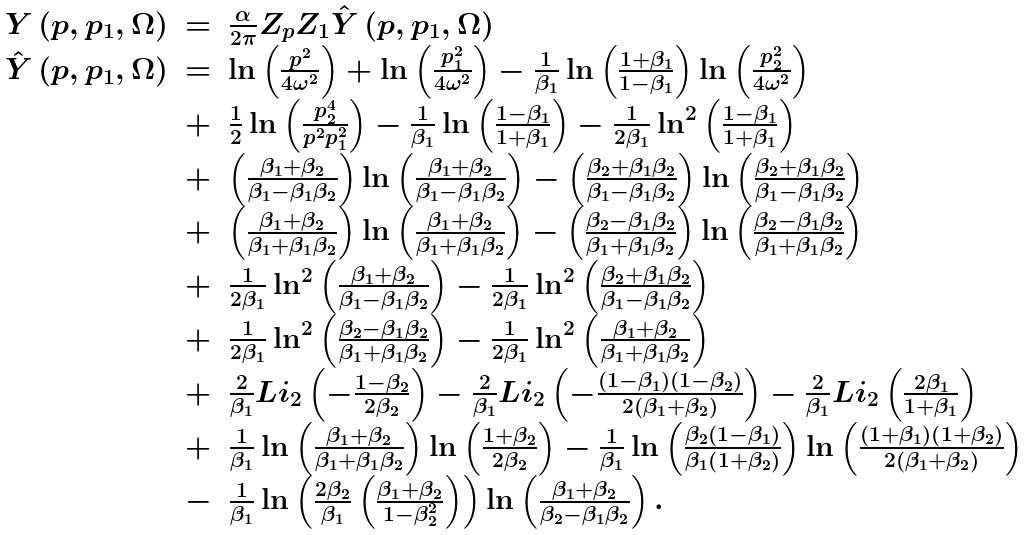<formula> <loc_0><loc_0><loc_500><loc_500>\begin{array} { l c l } Y \left ( p , p _ { 1 } , \Omega \right ) & = & \frac { \alpha } { 2 \pi } Z _ { p } Z _ { 1 } \hat { Y } \left ( p , p _ { 1 } , \Omega \right ) \\ \hat { Y } \left ( p , p _ { 1 } , \Omega \right ) & = & \ln \left ( \frac { p ^ { 2 } } { 4 \omega ^ { 2 } } \right ) + \ln \left ( \frac { p _ { 1 } ^ { 2 } } { 4 \omega ^ { 2 } } \right ) - \frac { 1 } { \beta _ { 1 } } \ln \left ( \frac { 1 + \beta _ { 1 } } { 1 - \beta _ { 1 } } \right ) \ln \left ( \frac { p _ { 2 } ^ { 2 } } { 4 \omega ^ { 2 } } \right ) \\ & + & \frac { 1 } { 2 } \ln \left ( \frac { p _ { 2 } ^ { 4 } } { p ^ { 2 } p _ { 1 } ^ { 2 } } \right ) - \frac { 1 } { \beta _ { 1 } } \ln \left ( \frac { 1 - \beta _ { 1 } } { 1 + \beta _ { 1 } } \right ) - \frac { 1 } { 2 \beta _ { 1 } } \ln ^ { 2 } \left ( \frac { 1 - \beta _ { 1 } } { 1 + \beta _ { 1 } } \right ) \\ & + & \left ( \frac { \beta _ { 1 } + \beta _ { 2 } } { \beta _ { 1 } - \beta _ { 1 } \beta _ { 2 } } \right ) \ln \left ( \frac { \beta _ { 1 } + \beta _ { 2 } } { \beta _ { 1 } - \beta _ { 1 } \beta _ { 2 } } \right ) - \left ( \frac { \beta _ { 2 } + \beta _ { 1 } \beta _ { 2 } } { \beta _ { 1 } - \beta _ { 1 } \beta _ { 2 } } \right ) \ln \left ( \frac { \beta _ { 2 } + \beta _ { 1 } \beta _ { 2 } } { \beta _ { 1 } - \beta _ { 1 } \beta _ { 2 } } \right ) \\ & + & \left ( \frac { \beta _ { 1 } + \beta _ { 2 } } { \beta _ { 1 } + \beta _ { 1 } \beta _ { 2 } } \right ) \ln \left ( \frac { \beta _ { 1 } + \beta _ { 2 } } { \beta _ { 1 } + \beta _ { 1 } \beta _ { 2 } } \right ) - \left ( \frac { \beta _ { 2 } - \beta _ { 1 } \beta _ { 2 } } { \beta _ { 1 } + \beta _ { 1 } \beta _ { 2 } } \right ) \ln \left ( \frac { \beta _ { 2 } - \beta _ { 1 } \beta _ { 2 } } { \beta _ { 1 } + \beta _ { 1 } \beta _ { 2 } } \right ) \\ & + & \frac { 1 } { 2 \beta _ { 1 } } \ln ^ { 2 } \left ( \frac { \beta _ { 1 } + \beta _ { 2 } } { \beta _ { 1 } - \beta _ { 1 } \beta _ { 2 } } \right ) - \frac { 1 } { 2 \beta _ { 1 } } \ln ^ { 2 } \left ( \frac { \beta _ { 2 } + \beta _ { 1 } \beta _ { 2 } } { \beta _ { 1 } - \beta _ { 1 } \beta _ { 2 } } \right ) \\ & + & \frac { 1 } { 2 \beta _ { 1 } } \ln ^ { 2 } \left ( \frac { \beta _ { 2 } - \beta _ { 1 } \beta _ { 2 } } { \beta _ { 1 } + \beta _ { 1 } \beta _ { 2 } } \right ) - \frac { 1 } { 2 \beta _ { 1 } } \ln ^ { 2 } \left ( \frac { \beta _ { 1 } + \beta _ { 2 } } { \beta _ { 1 } + \beta _ { 1 } \beta _ { 2 } } \right ) \\ & + & \frac { 2 } { \beta _ { 1 } } L i _ { 2 } \left ( - \frac { 1 - \beta _ { 2 } } { 2 \beta _ { 2 } } \right ) - \frac { 2 } { \beta _ { 1 } } L i _ { 2 } \left ( - \frac { \left ( 1 - \beta _ { 1 } \right ) \left ( 1 - \beta _ { 2 } \right ) } { 2 \left ( \beta _ { 1 } + \beta _ { 2 } \right ) } \right ) - \frac { 2 } { \beta _ { 1 } } L i _ { 2 } \left ( \frac { 2 \beta _ { 1 } } { 1 + \beta _ { 1 } } \right ) \\ & + & \frac { 1 } { \beta _ { 1 } } \ln \left ( \frac { \beta _ { 1 } + \beta _ { 2 } } { \beta _ { 1 } + \beta _ { 1 } \beta _ { 2 } } \right ) \ln \left ( \frac { 1 + \beta _ { 2 } } { 2 \beta _ { 2 } } \right ) - \frac { 1 } { \beta _ { 1 } } \ln \left ( \frac { \beta _ { 2 } \left ( 1 - \beta _ { 1 } \right ) } { \beta _ { 1 } \left ( 1 + \beta _ { 2 } \right ) } \right ) \ln \left ( \frac { \left ( 1 + \beta _ { 1 } \right ) \left ( 1 + \beta _ { 2 } \right ) } { 2 \left ( \beta _ { 1 } + \beta _ { 2 } \right ) } \right ) \\ & - & \frac { 1 } { \beta _ { 1 } } \ln \left ( \frac { 2 \beta _ { 2 } } { \beta _ { 1 } } \left ( \frac { \beta _ { 1 } + \beta _ { 2 } } { 1 - \beta _ { 2 } ^ { 2 } } \right ) \right ) \ln \left ( \frac { \beta _ { 1 } + \beta _ { 2 } } { \beta _ { 2 } - \beta _ { 1 } \beta _ { 2 } } \right ) . \end{array}</formula> 